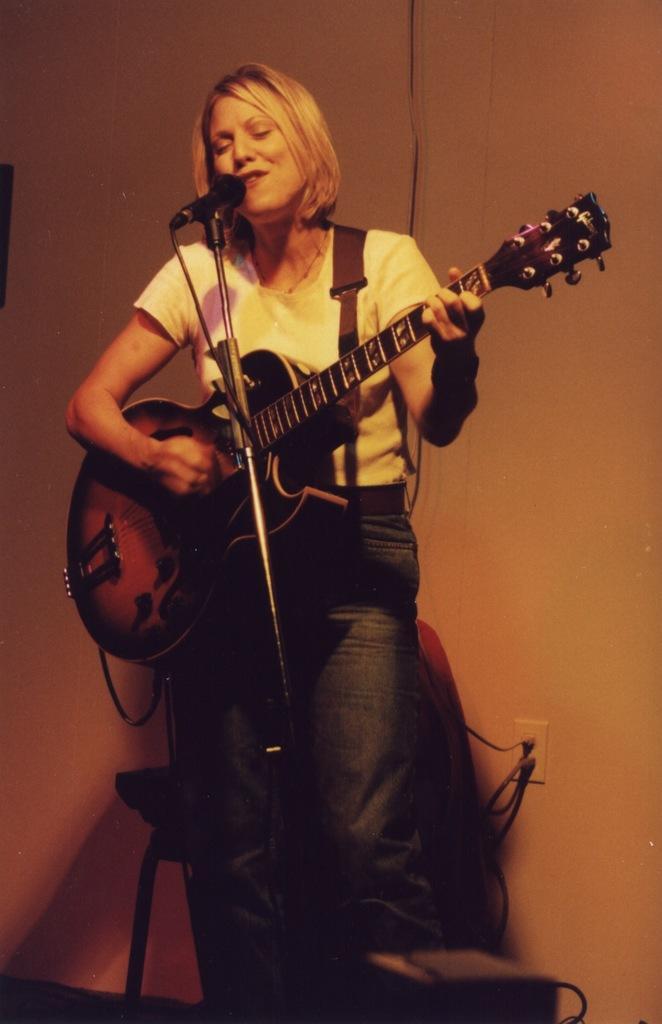Describe this image in one or two sentences. In this image I see a woman who is holding a guitar and standing in front of a mic. In the background I can see the wall. 